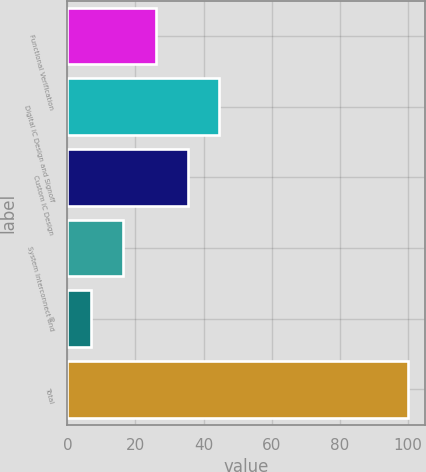<chart> <loc_0><loc_0><loc_500><loc_500><bar_chart><fcel>Functional Verification<fcel>Digital IC Design and Signoff<fcel>Custom IC Design<fcel>System Interconnect and<fcel>IP<fcel>Total<nl><fcel>26<fcel>44.6<fcel>35.3<fcel>16.3<fcel>7<fcel>100<nl></chart> 